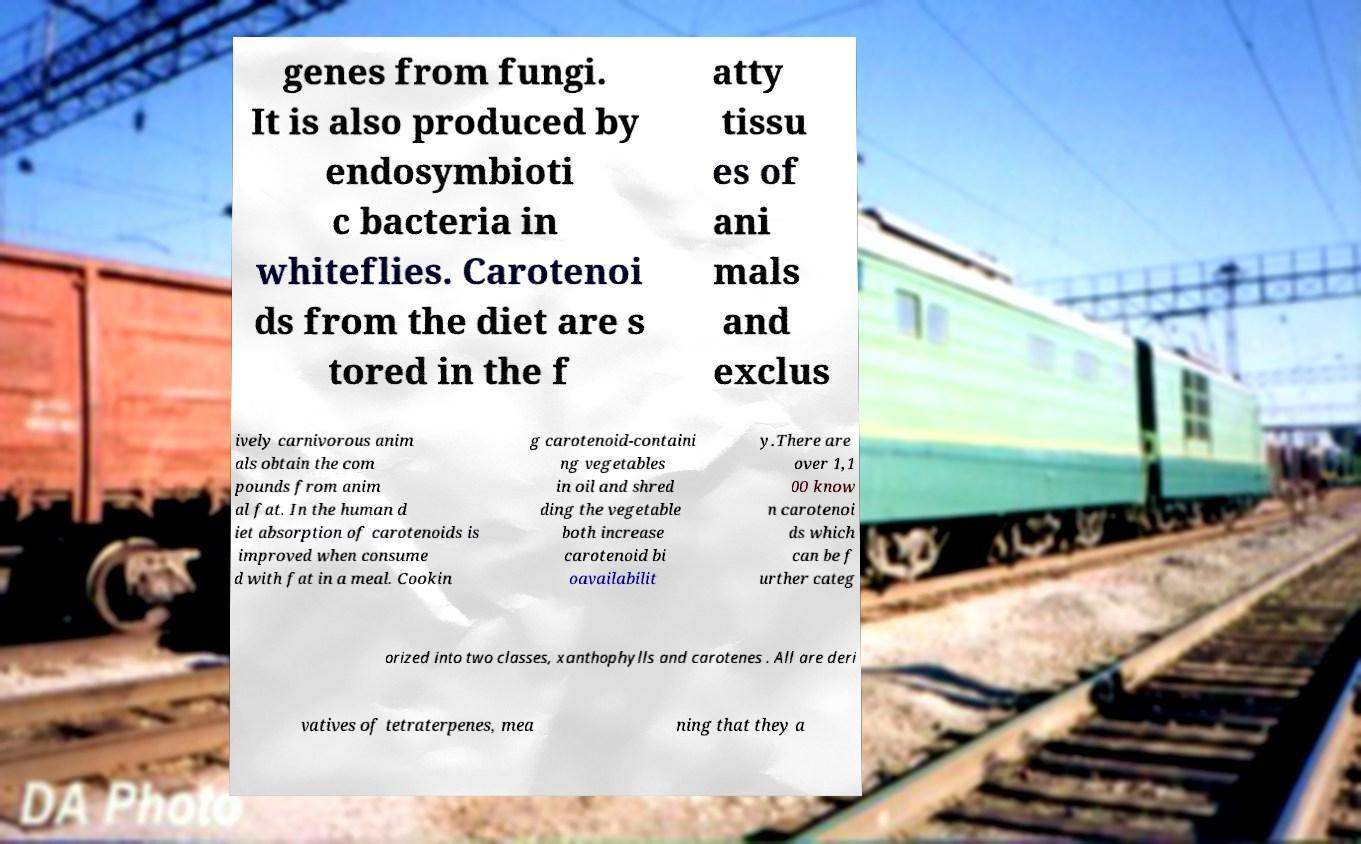Could you assist in decoding the text presented in this image and type it out clearly? genes from fungi. It is also produced by endosymbioti c bacteria in whiteflies. Carotenoi ds from the diet are s tored in the f atty tissu es of ani mals and exclus ively carnivorous anim als obtain the com pounds from anim al fat. In the human d iet absorption of carotenoids is improved when consume d with fat in a meal. Cookin g carotenoid-containi ng vegetables in oil and shred ding the vegetable both increase carotenoid bi oavailabilit y.There are over 1,1 00 know n carotenoi ds which can be f urther categ orized into two classes, xanthophylls and carotenes . All are deri vatives of tetraterpenes, mea ning that they a 